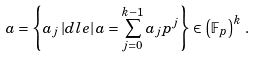Convert formula to latex. <formula><loc_0><loc_0><loc_500><loc_500>a & = \left \{ a _ { j } \, | d l e | \, a = \sum _ { j = 0 } ^ { k - 1 } a _ { j } p ^ { j } \right \} \in \left ( \mathbb { F } _ { p } \right ) ^ { k } \, .</formula> 